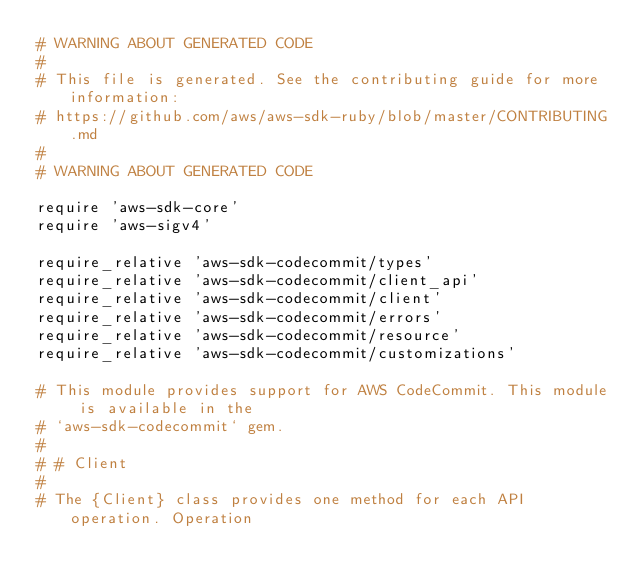Convert code to text. <code><loc_0><loc_0><loc_500><loc_500><_Ruby_># WARNING ABOUT GENERATED CODE
#
# This file is generated. See the contributing guide for more information:
# https://github.com/aws/aws-sdk-ruby/blob/master/CONTRIBUTING.md
#
# WARNING ABOUT GENERATED CODE

require 'aws-sdk-core'
require 'aws-sigv4'

require_relative 'aws-sdk-codecommit/types'
require_relative 'aws-sdk-codecommit/client_api'
require_relative 'aws-sdk-codecommit/client'
require_relative 'aws-sdk-codecommit/errors'
require_relative 'aws-sdk-codecommit/resource'
require_relative 'aws-sdk-codecommit/customizations'

# This module provides support for AWS CodeCommit. This module is available in the
# `aws-sdk-codecommit` gem.
#
# # Client
#
# The {Client} class provides one method for each API operation. Operation</code> 